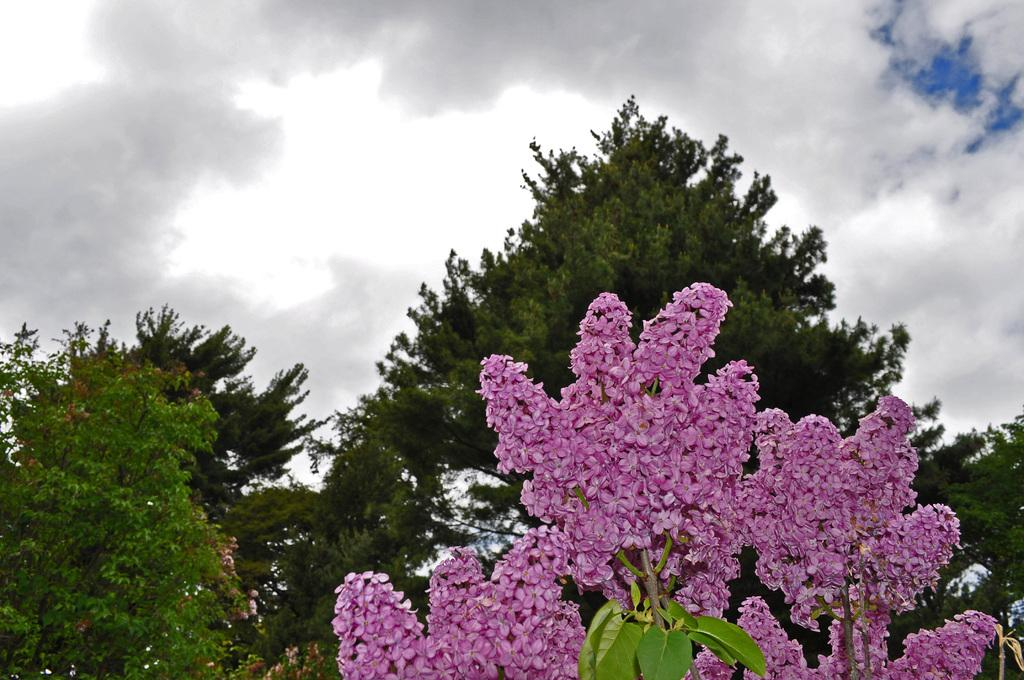What type of vegetation can be seen in the image? There are trees in the image. What is the color of the leaves on the trees? The leaves on the trees have a purple color. What can be seen in the sky in the image? There are clouds visible in the image. What part of the sky is visible in the image? The sky is visible in the image. What type of meal is being prepared in the image? There is no meal preparation visible in the image; it only features trees with purple leaves, clouds, and the sky. Can you see a carriage in the image? There is no carriage present in the image. 